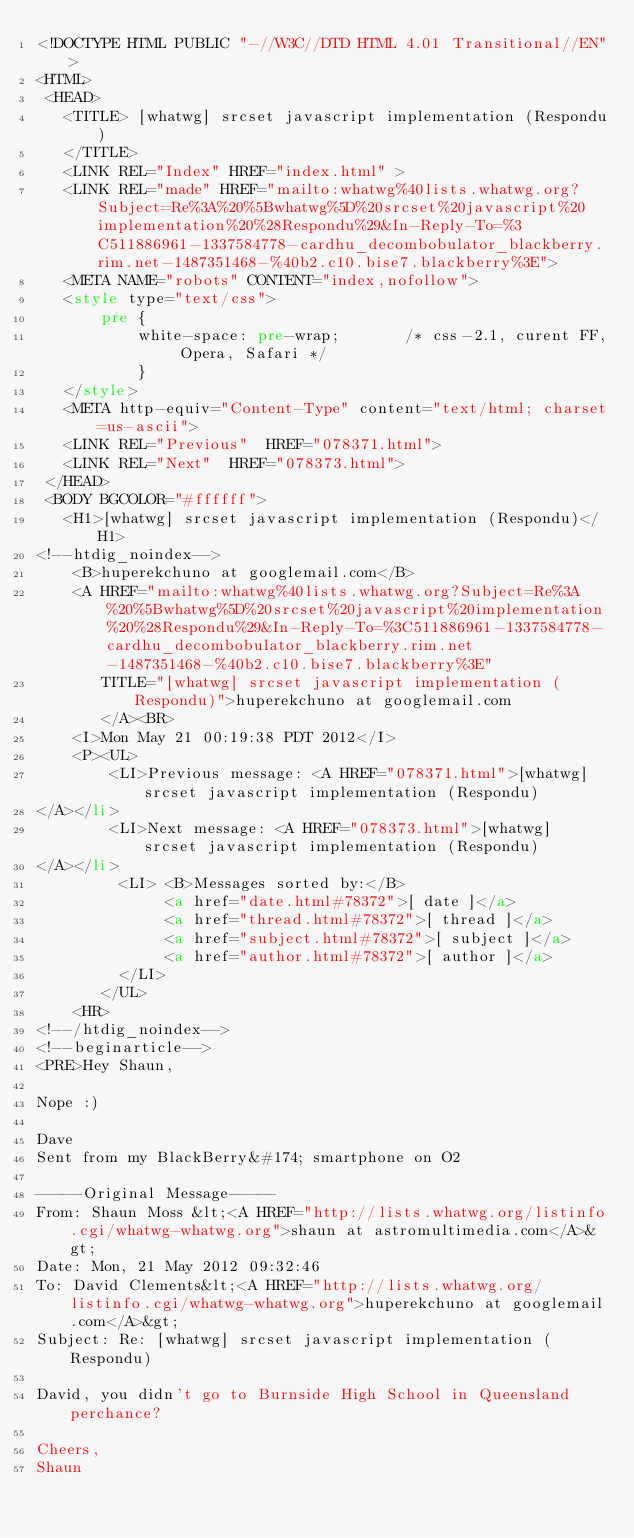Convert code to text. <code><loc_0><loc_0><loc_500><loc_500><_HTML_><!DOCTYPE HTML PUBLIC "-//W3C//DTD HTML 4.01 Transitional//EN">
<HTML>
 <HEAD>
   <TITLE> [whatwg] srcset javascript implementation (Respondu)
   </TITLE>
   <LINK REL="Index" HREF="index.html" >
   <LINK REL="made" HREF="mailto:whatwg%40lists.whatwg.org?Subject=Re%3A%20%5Bwhatwg%5D%20srcset%20javascript%20implementation%20%28Respondu%29&In-Reply-To=%3C511886961-1337584778-cardhu_decombobulator_blackberry.rim.net-1487351468-%40b2.c10.bise7.blackberry%3E">
   <META NAME="robots" CONTENT="index,nofollow">
   <style type="text/css">
       pre {
           white-space: pre-wrap;       /* css-2.1, curent FF, Opera, Safari */
           }
   </style>
   <META http-equiv="Content-Type" content="text/html; charset=us-ascii">
   <LINK REL="Previous"  HREF="078371.html">
   <LINK REL="Next"  HREF="078373.html">
 </HEAD>
 <BODY BGCOLOR="#ffffff">
   <H1>[whatwg] srcset javascript implementation (Respondu)</H1>
<!--htdig_noindex-->
    <B>huperekchuno at googlemail.com</B> 
    <A HREF="mailto:whatwg%40lists.whatwg.org?Subject=Re%3A%20%5Bwhatwg%5D%20srcset%20javascript%20implementation%20%28Respondu%29&In-Reply-To=%3C511886961-1337584778-cardhu_decombobulator_blackberry.rim.net-1487351468-%40b2.c10.bise7.blackberry%3E"
       TITLE="[whatwg] srcset javascript implementation (Respondu)">huperekchuno at googlemail.com
       </A><BR>
    <I>Mon May 21 00:19:38 PDT 2012</I>
    <P><UL>
        <LI>Previous message: <A HREF="078371.html">[whatwg] srcset javascript implementation (Respondu)
</A></li>
        <LI>Next message: <A HREF="078373.html">[whatwg] srcset javascript implementation (Respondu)
</A></li>
         <LI> <B>Messages sorted by:</B> 
              <a href="date.html#78372">[ date ]</a>
              <a href="thread.html#78372">[ thread ]</a>
              <a href="subject.html#78372">[ subject ]</a>
              <a href="author.html#78372">[ author ]</a>
         </LI>
       </UL>
    <HR>  
<!--/htdig_noindex-->
<!--beginarticle-->
<PRE>Hey Shaun,

Nope :)

Dave
Sent from my BlackBerry&#174; smartphone on O2

-----Original Message-----
From: Shaun Moss &lt;<A HREF="http://lists.whatwg.org/listinfo.cgi/whatwg-whatwg.org">shaun at astromultimedia.com</A>&gt;
Date: Mon, 21 May 2012 09:32:46 
To: David Clements&lt;<A HREF="http://lists.whatwg.org/listinfo.cgi/whatwg-whatwg.org">huperekchuno at googlemail.com</A>&gt;
Subject: Re: [whatwg] srcset javascript implementation (Respondu)

David, you didn't go to Burnside High School in Queensland perchance?

Cheers,
Shaun
</code> 